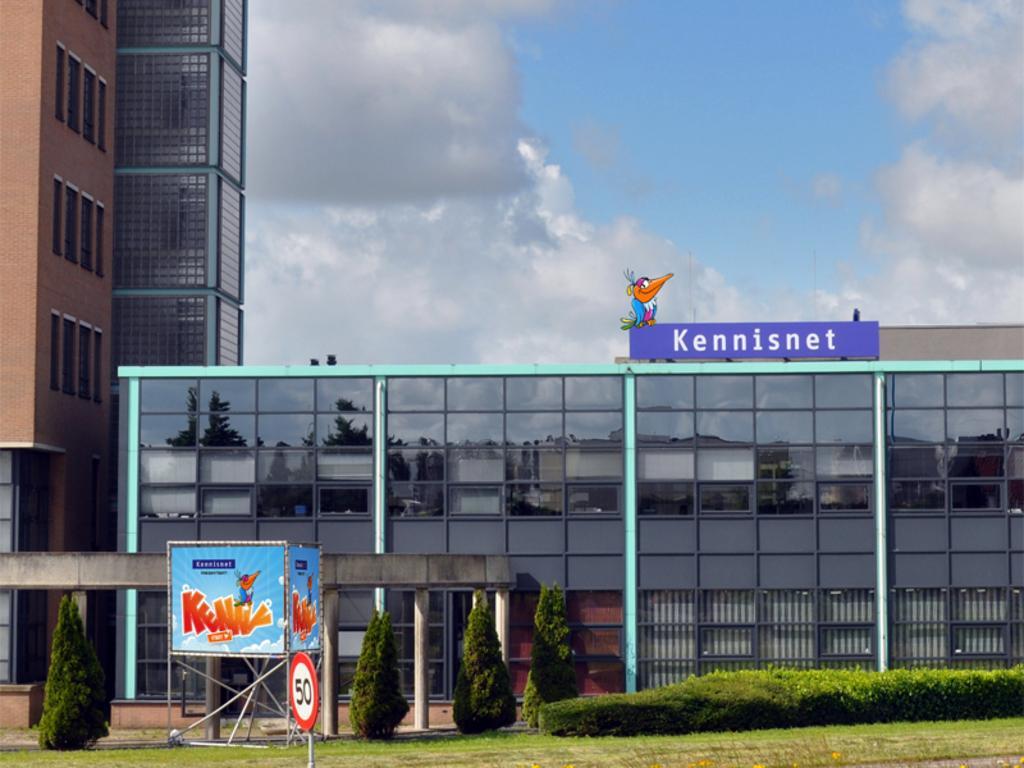In one or two sentences, can you explain what this image depicts? In this image there are buildings. In front of the buildings there are trees, hedges and grass on the ground. There is a board. To the right there is a board with text on the building. At the top there is the sky. 